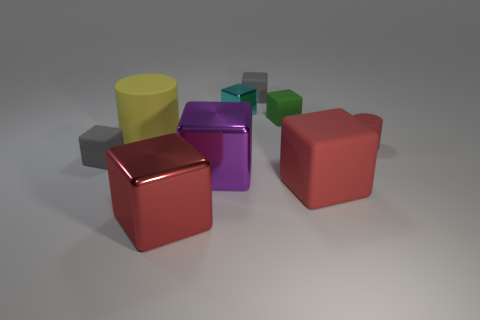What is the size of the matte object that is the same color as the large rubber cube?
Your response must be concise. Small. What number of big red things are made of the same material as the red cylinder?
Give a very brief answer. 1. There is a big metal object that is the same color as the large matte block; what is its shape?
Your answer should be compact. Cube. Is the number of tiny cyan metallic objects that are to the right of the big red matte thing the same as the number of big blue metallic balls?
Keep it short and to the point. Yes. There is a metallic cube that is right of the big purple object; what size is it?
Make the answer very short. Small. How many tiny things are cyan shiny things or cylinders?
Provide a succinct answer. 2. What is the color of the other big metal thing that is the same shape as the purple object?
Make the answer very short. Red. Do the cyan thing and the red matte cylinder have the same size?
Your response must be concise. Yes. How many objects are either big brown balls or cylinders that are to the right of the red metallic cube?
Make the answer very short. 1. The large matte thing that is behind the small matte thing that is left of the purple metallic thing is what color?
Provide a short and direct response. Yellow. 